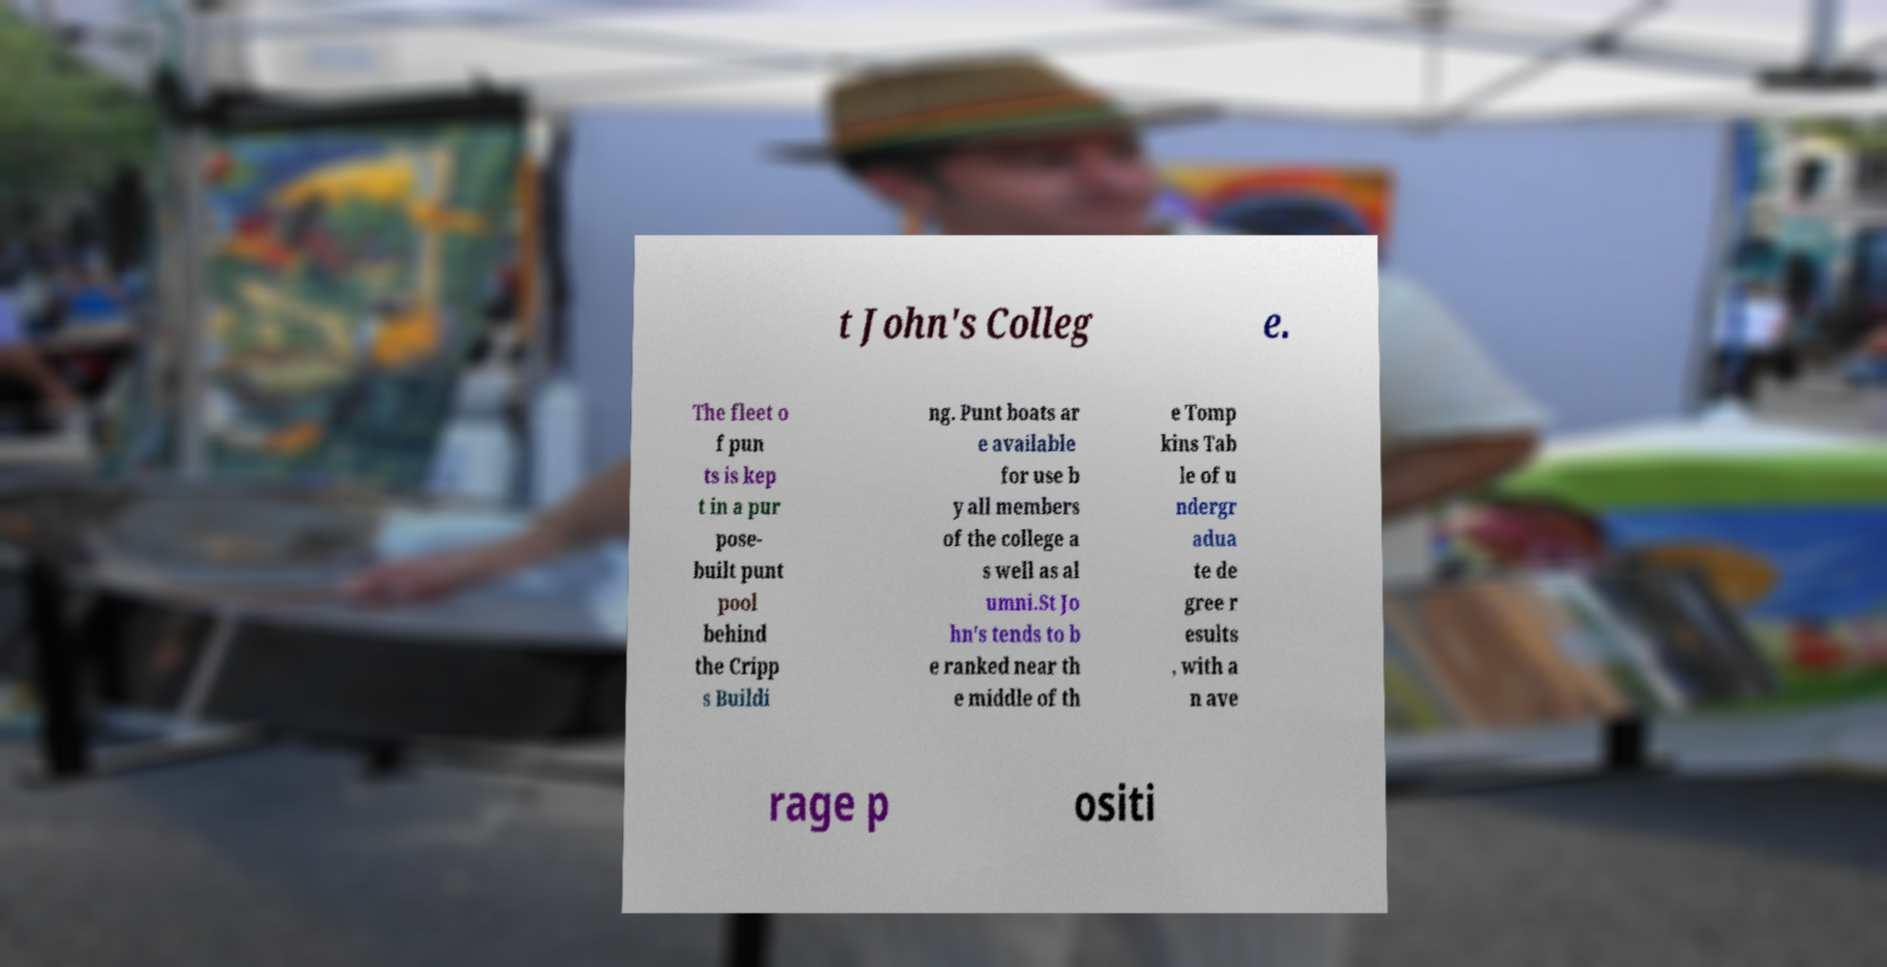Could you assist in decoding the text presented in this image and type it out clearly? t John's Colleg e. The fleet o f pun ts is kep t in a pur pose- built punt pool behind the Cripp s Buildi ng. Punt boats ar e available for use b y all members of the college a s well as al umni.St Jo hn's tends to b e ranked near th e middle of th e Tomp kins Tab le of u ndergr adua te de gree r esults , with a n ave rage p ositi 